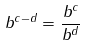<formula> <loc_0><loc_0><loc_500><loc_500>b ^ { c - d } = \frac { b ^ { c } } { b ^ { d } }</formula> 